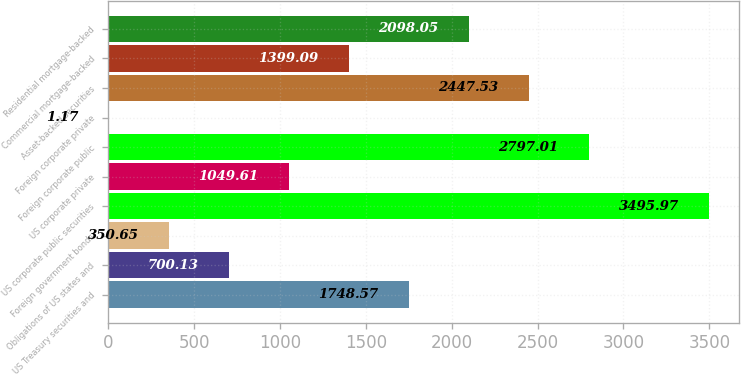Convert chart to OTSL. <chart><loc_0><loc_0><loc_500><loc_500><bar_chart><fcel>US Treasury securities and<fcel>Obligations of US states and<fcel>Foreign government bonds<fcel>US corporate public securities<fcel>US corporate private<fcel>Foreign corporate public<fcel>Foreign corporate private<fcel>Asset-backed securities<fcel>Commercial mortgage-backed<fcel>Residential mortgage-backed<nl><fcel>1748.57<fcel>700.13<fcel>350.65<fcel>3495.97<fcel>1049.61<fcel>2797.01<fcel>1.17<fcel>2447.53<fcel>1399.09<fcel>2098.05<nl></chart> 